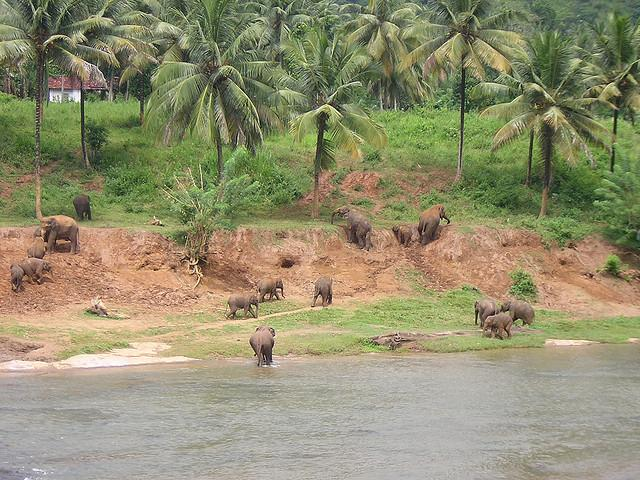What is a unique feature of these animals? trunk 